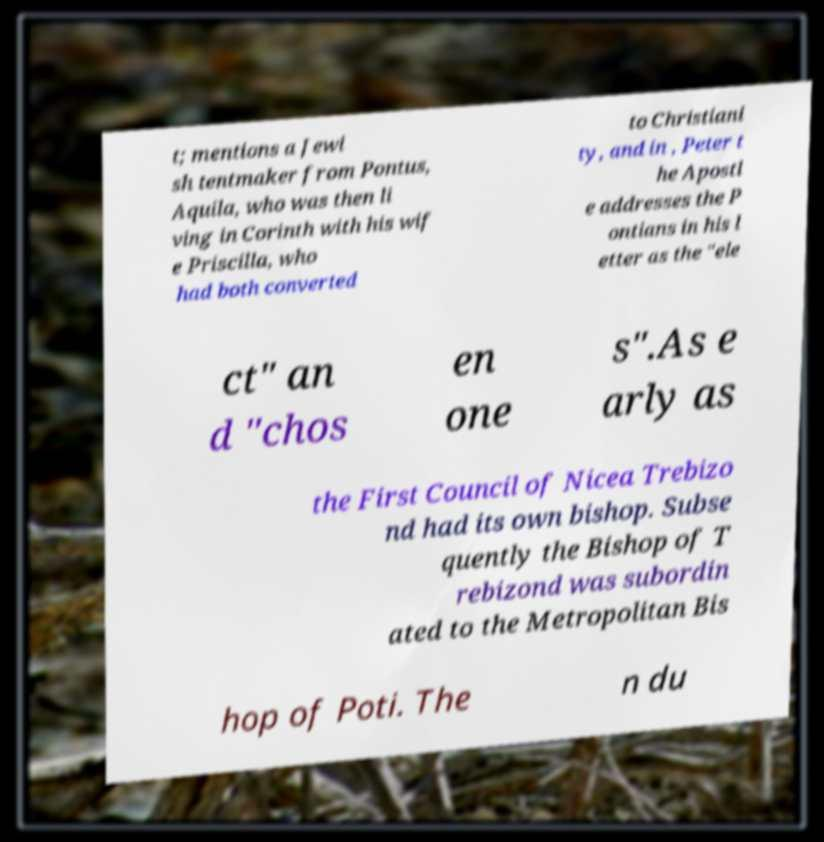Please read and relay the text visible in this image. What does it say? t; mentions a Jewi sh tentmaker from Pontus, Aquila, who was then li ving in Corinth with his wif e Priscilla, who had both converted to Christiani ty, and in , Peter t he Apostl e addresses the P ontians in his l etter as the "ele ct" an d "chos en one s".As e arly as the First Council of Nicea Trebizo nd had its own bishop. Subse quently the Bishop of T rebizond was subordin ated to the Metropolitan Bis hop of Poti. The n du 